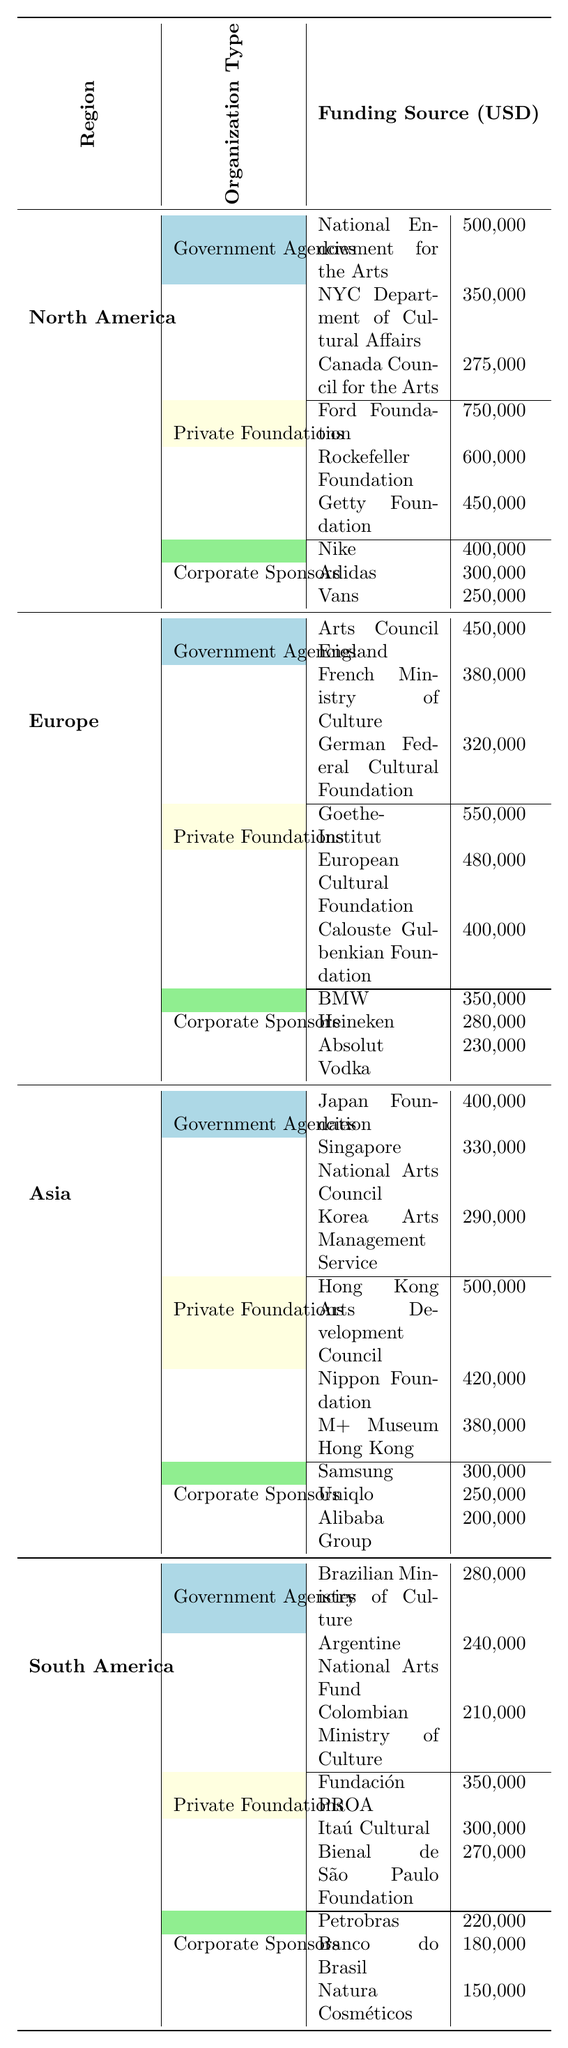What is the highest funding source in North America for street art? The table shows that the highest funding source in North America is the Ford Foundation with $750,000.
Answer: $750,000 Which continent has the lowest total funding from Corporate Sponsors? First, we sum the Corporate Sponsors funding for each continent: North America: $950,000, Europe: $860,000, Asia: $750,000, South America: $550,000. South America has the lowest total funding from Corporate Sponsors at $550,000.
Answer: South America Is the National Endowment for the Arts the only funding source listed for Government Agencies in North America? The table lists three funding sources for Government Agencies in North America: the National Endowment for the Arts, NYC Department of Cultural Affairs, and Canada Council for the Arts. Therefore, it is not the only source.
Answer: No What is the total funding from Private Foundations in Europe? For Europe, summing the Private Foundations funding gives: Goethe-Institut ($550,000) + European Cultural Foundation ($480,000) + Calouste Gulbenkian Foundation ($400,000) = $1,430,000.
Answer: $1,430,000 Which region has the highest total funding from Government Agencies? First, we calculate the total funding from Government Agencies for each region: North America: $1,125,000, Europe: $1,150,000, Asia: $1,020,000, South America: $731,000. The total from Government Agencies is highest in Europe with $1,150,000.
Answer: Europe Is there more funding from Corporate Sponsors in Asia than in North America? The total funding from Corporate Sponsors is $750,000 in Asia and $950,000 in North America. Since $950,000 is greater than $750,000, the claim is false.
Answer: No What is the average funding amount from Government Agencies across all regions? We sum the Government Agencies funding: North America ($1,125,000) + Europe ($1,150,000) + Asia ($1,020,000) + South America ($731,000) = $4,026,000. There are 4 regions, so the average is $4,026,000 / 4 = $1,006,500.
Answer: $1,006,500 How much more funding is provided by Private Foundations in Asia compared to South America? For Asia, the total funding from Private Foundations is $1,300,000 (Hong Kong Arts Development Council + Nippon Foundation + M+ Museum Hong Kong). For South America, the total is $920,000. The difference is $1,300,000 - $920,000 = $380,000.
Answer: $380,000 Is the funding from the Bayern Corporation higher than the funding received from any Foundation in North America? BMW received $350,000 as a Corporate Sponsor, while the foundations in North America are: Ford Foundation ($750,000), Rockefeller Foundation ($600,000), and Getty Foundation ($450,000). All Foundations in North America have higher amounts than BMW.
Answer: No Which funding source contributes the least in South America? The table shows that the Corporate Sponsor contributing the least in South America is Natura Cosméticos with $150,000.
Answer: $150,000 What is the total Corporate Sponsors funding for North America and Europe combined? For North America, Corporate Sponsors total $950,000. For Europe, it is $860,000. Therefore, the combined total is $950,000 + $860,000 = $1,810,000.
Answer: $1,810,000 